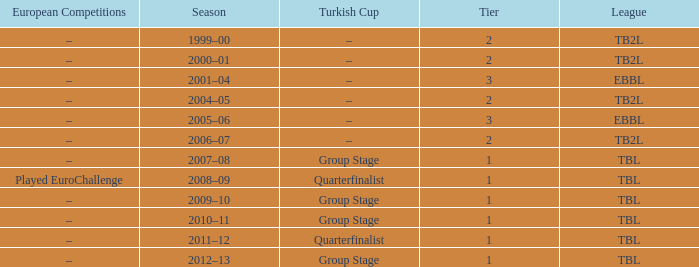Season of 2012–13 is what league? TBL. 